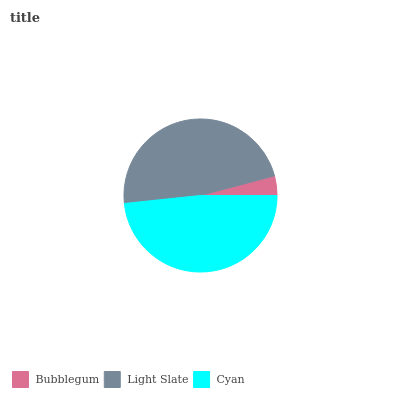Is Bubblegum the minimum?
Answer yes or no. Yes. Is Cyan the maximum?
Answer yes or no. Yes. Is Light Slate the minimum?
Answer yes or no. No. Is Light Slate the maximum?
Answer yes or no. No. Is Light Slate greater than Bubblegum?
Answer yes or no. Yes. Is Bubblegum less than Light Slate?
Answer yes or no. Yes. Is Bubblegum greater than Light Slate?
Answer yes or no. No. Is Light Slate less than Bubblegum?
Answer yes or no. No. Is Light Slate the high median?
Answer yes or no. Yes. Is Light Slate the low median?
Answer yes or no. Yes. Is Bubblegum the high median?
Answer yes or no. No. Is Bubblegum the low median?
Answer yes or no. No. 